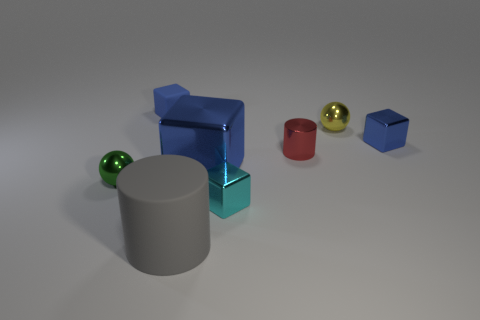What number of things are things behind the tiny red cylinder or metal things that are to the right of the big gray rubber object?
Provide a short and direct response. 6. Is there a big gray rubber object of the same shape as the red shiny thing?
Offer a very short reply. Yes. What material is the large thing that is the same color as the matte cube?
Ensure brevity in your answer.  Metal. How many rubber things are either cyan things or yellow things?
Your answer should be compact. 0. What is the shape of the cyan object?
Your response must be concise. Cube. How many big cubes are the same material as the small cyan object?
Keep it short and to the point. 1. What color is the tiny cylinder that is made of the same material as the small cyan block?
Provide a short and direct response. Red. There is a metal block to the right of the cyan thing; is it the same size as the cyan thing?
Offer a very short reply. Yes. The small rubber object that is the same shape as the large blue thing is what color?
Offer a very short reply. Blue. There is a big object in front of the metal ball that is in front of the cylinder that is to the right of the gray cylinder; what shape is it?
Keep it short and to the point. Cylinder. 